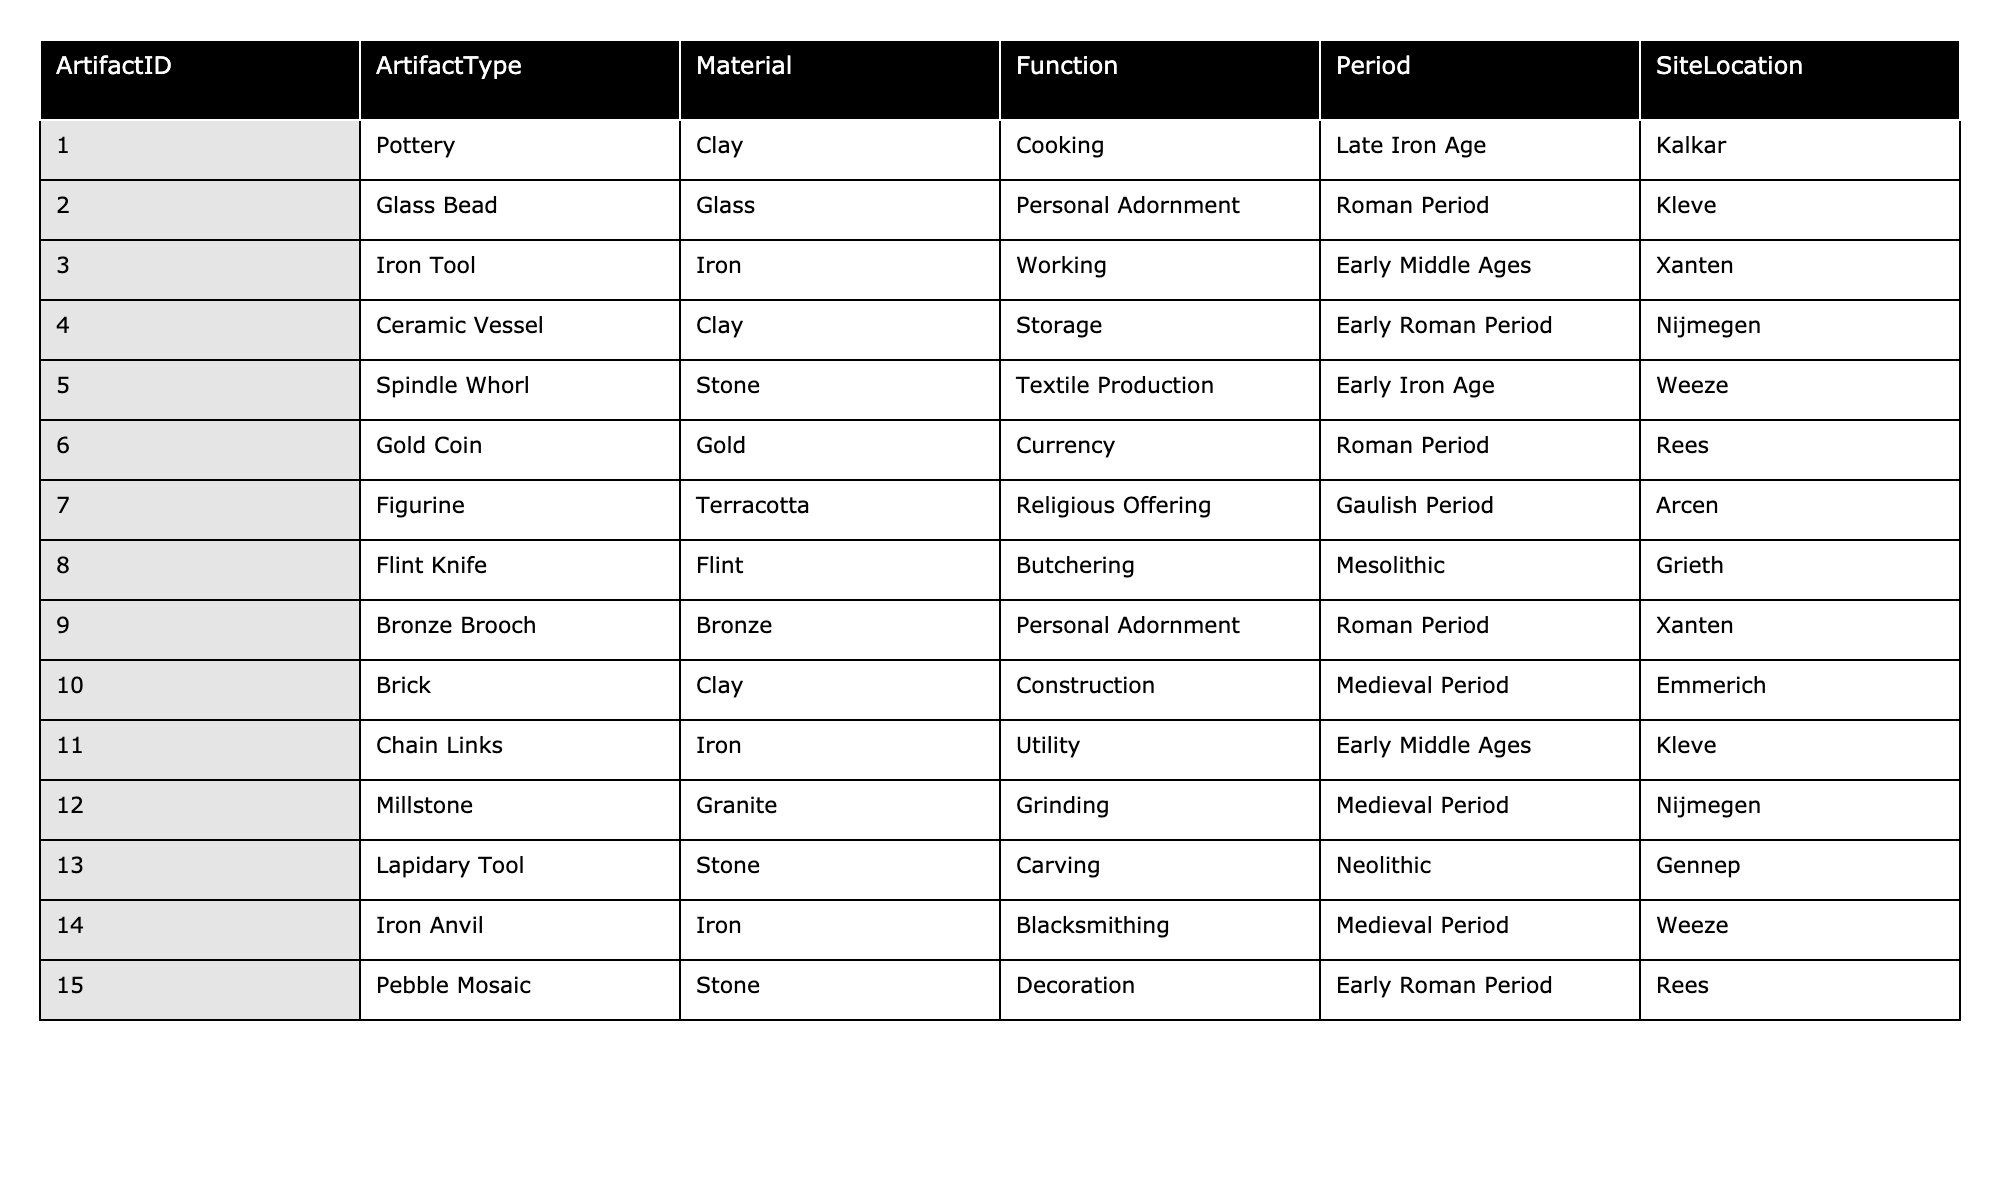What is the most common material used for artifacts in the table? The table lists various artifacts and their materials. By counting the occurrences, Clay appears 4 times (Pottery, Ceramic Vessel, Brick), making it the most common material.
Answer: Clay How many artifacts were found from the Roman Period? The table shows five artifacts classified under the Roman Period: Glass Bead, Bronze Brooch, and Ceramic Vessel; thus, there are three artifacts from this period.
Answer: 3 Is there any artifact from the Neolithic period in the table? Looking at the Period column, the table has one artifact, the Lapidary Tool, listed under the Neolithic period, confirming its presence.
Answer: Yes What types of materials are used for personal adornment artifacts? The table shows two artifacts for personal adornment: Glass Bead (Glass) and Bronze Brooch (Bronze), both classified under the ArtifactType 'Personal Adornment'.
Answer: Glass and Bronze Which artifact is used for textile production, and what is its material? The Spindle Whorl is identified as an artifact for textile production with Stone as its material, specifically listed in the Function column.
Answer: Spindle Whorl, Stone How many different functions are represented by the artifacts from the Early Middle Ages period? In the table, two artifacts are from the Early Middle Ages period: Iron Tool (Working) and Chain Links (Utility). Collectively these represent two distinct functions.
Answer: 2 Which artifact from the Early Iron Age is used for textile production? The table displays the Spindle Whorl as the artifact from the Early Iron Age categorized specifically for textile production as its function.
Answer: Spindle Whorl Determine the total number of artifacts that fall under the Utility function. The table indicates that there are two artifacts categorized as Utility: Chain Links and Iron Anvil. Hence, the total is two artifacts.
Answer: 2 Was there any artifact made of Gold found in the excavations? The table lists one artifact, the Gold Coin, which confirms that a gold artifact was indeed found in the excavations.
Answer: Yes What is the function of the Iron Anvil artifact? The table specifies that the Iron Anvil has the function of Blacksmithing, according to the Function column.
Answer: Blacksmithing 